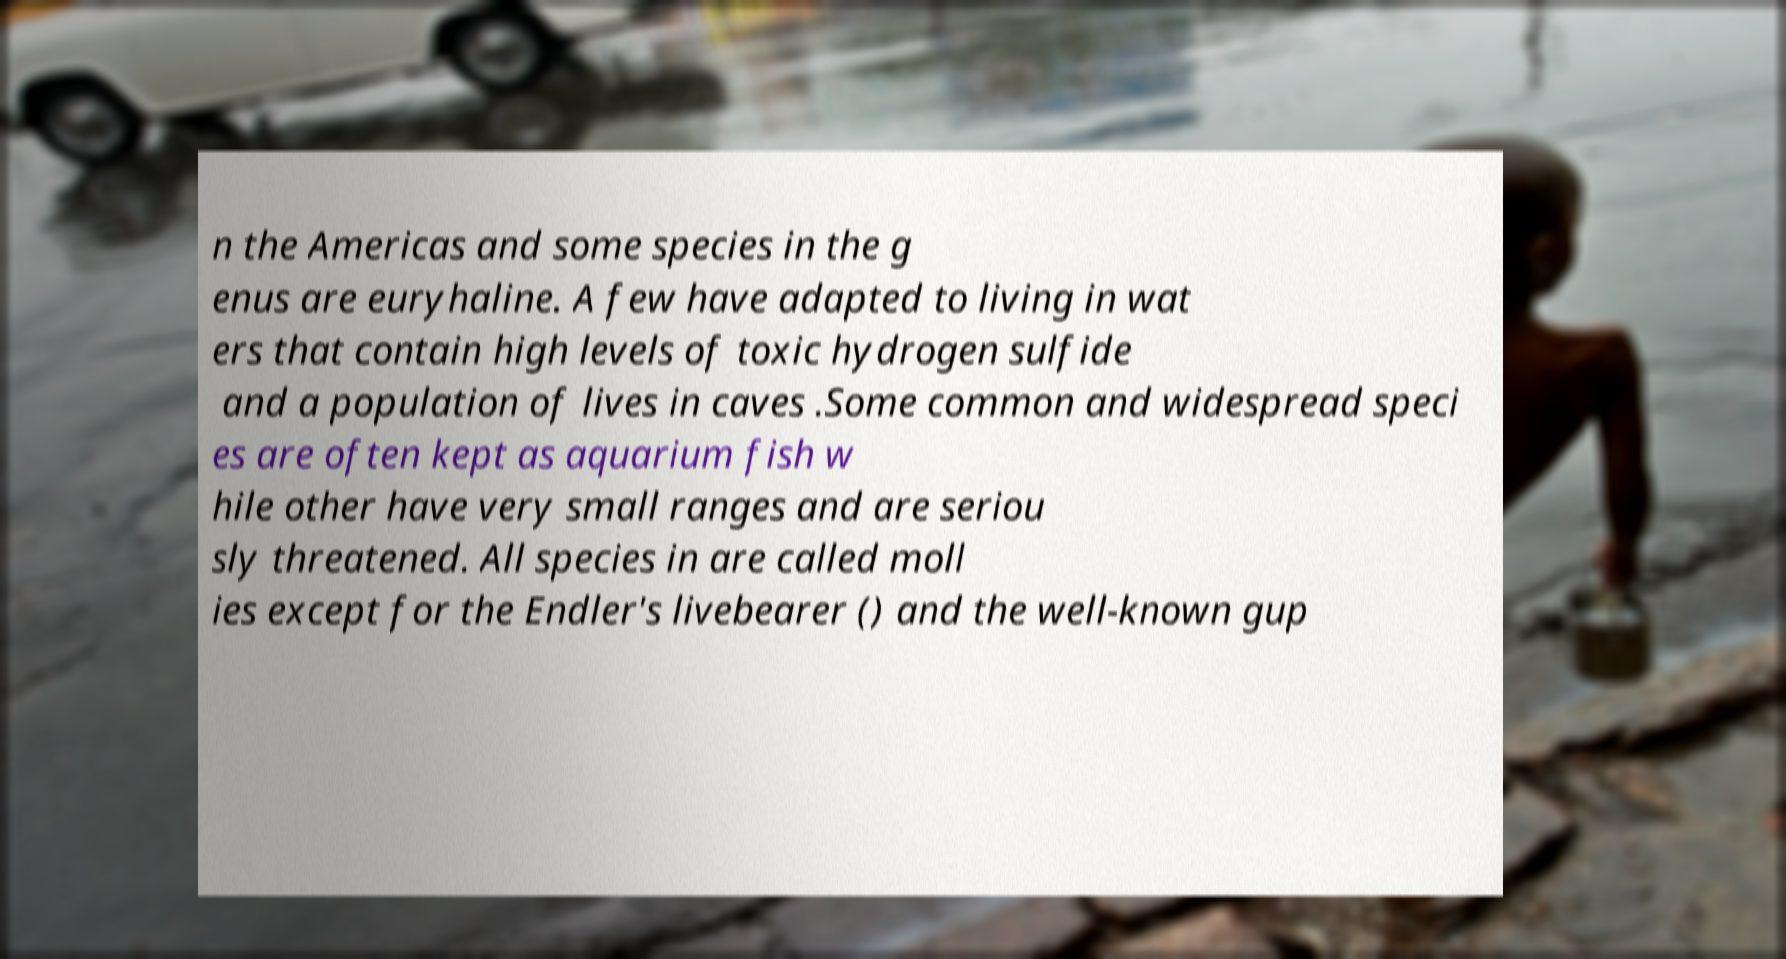For documentation purposes, I need the text within this image transcribed. Could you provide that? n the Americas and some species in the g enus are euryhaline. A few have adapted to living in wat ers that contain high levels of toxic hydrogen sulfide and a population of lives in caves .Some common and widespread speci es are often kept as aquarium fish w hile other have very small ranges and are seriou sly threatened. All species in are called moll ies except for the Endler's livebearer () and the well-known gup 